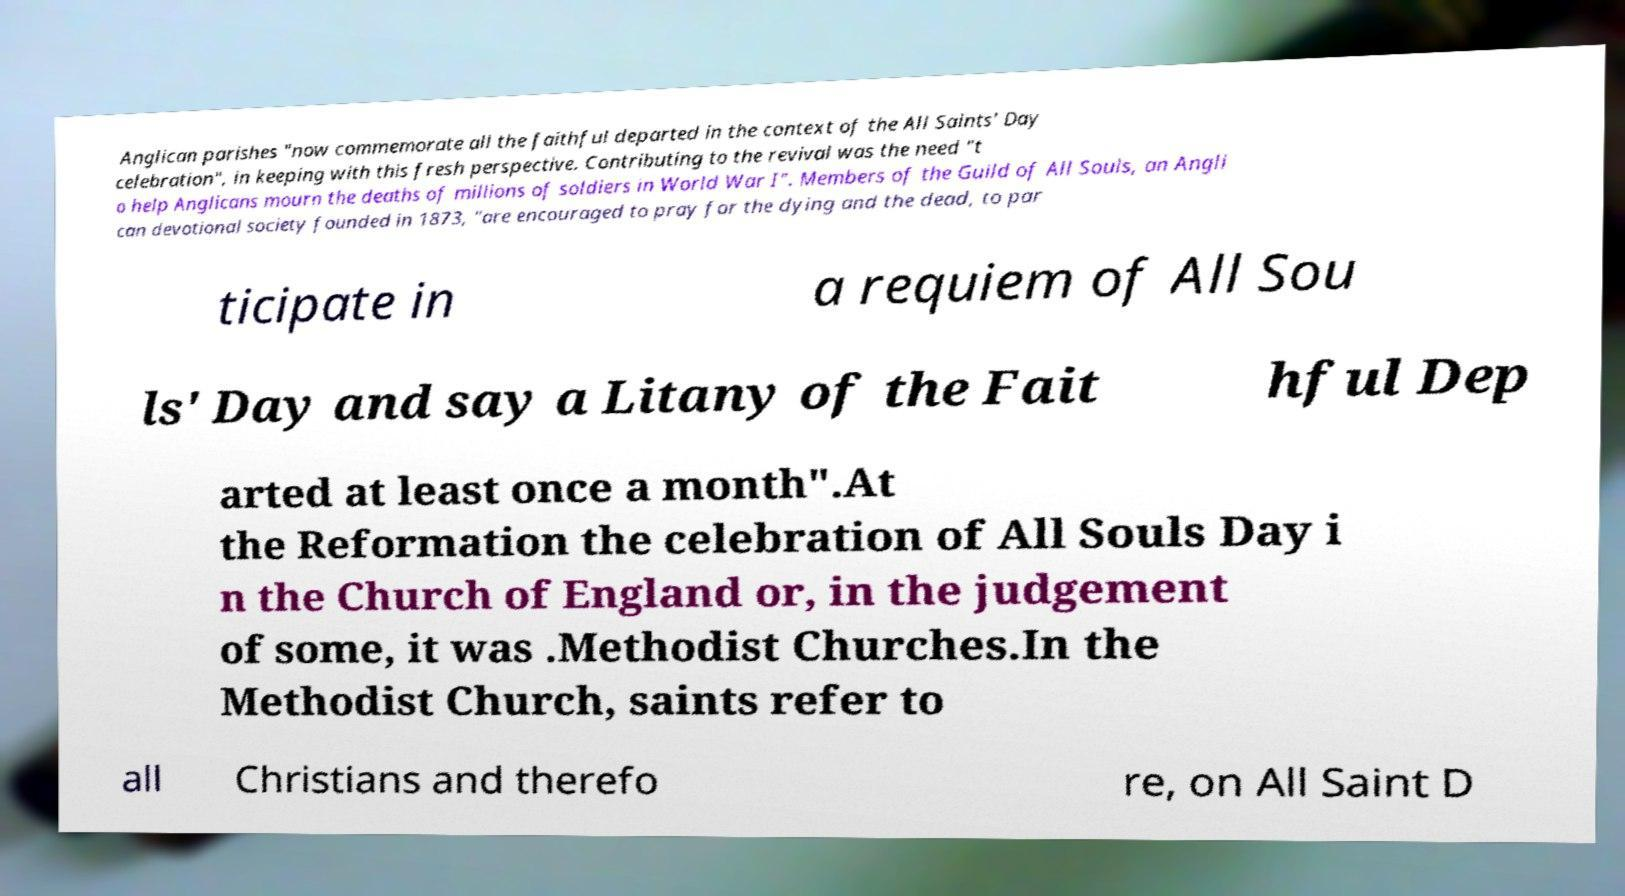What messages or text are displayed in this image? I need them in a readable, typed format. Anglican parishes "now commemorate all the faithful departed in the context of the All Saints' Day celebration", in keeping with this fresh perspective. Contributing to the revival was the need "t o help Anglicans mourn the deaths of millions of soldiers in World War I". Members of the Guild of All Souls, an Angli can devotional society founded in 1873, "are encouraged to pray for the dying and the dead, to par ticipate in a requiem of All Sou ls' Day and say a Litany of the Fait hful Dep arted at least once a month".At the Reformation the celebration of All Souls Day i n the Church of England or, in the judgement of some, it was .Methodist Churches.In the Methodist Church, saints refer to all Christians and therefo re, on All Saint D 